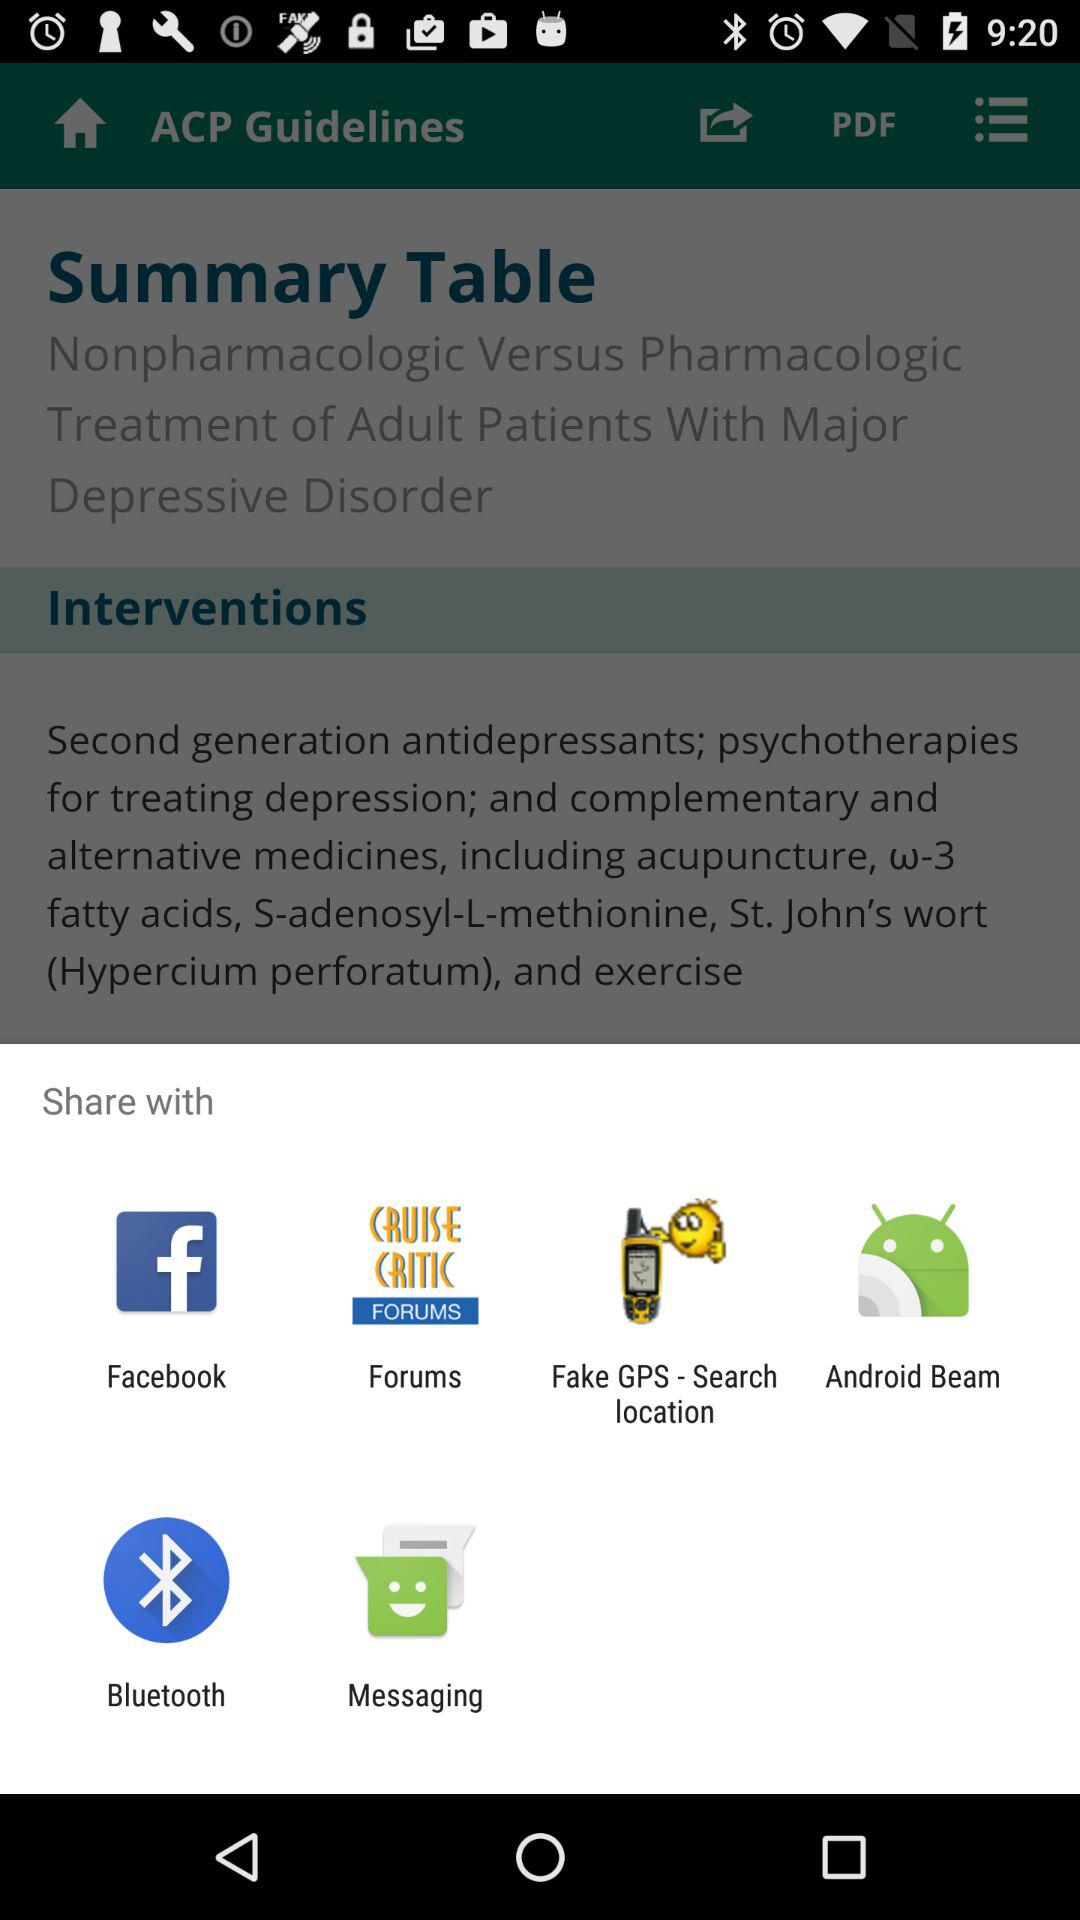With which applications and mediums can the content be shared? The content can be shared with "Facebook", "Forums", "Fake GPS - Search location", "Android Beam", "Bluetooth" and "Messaging". 